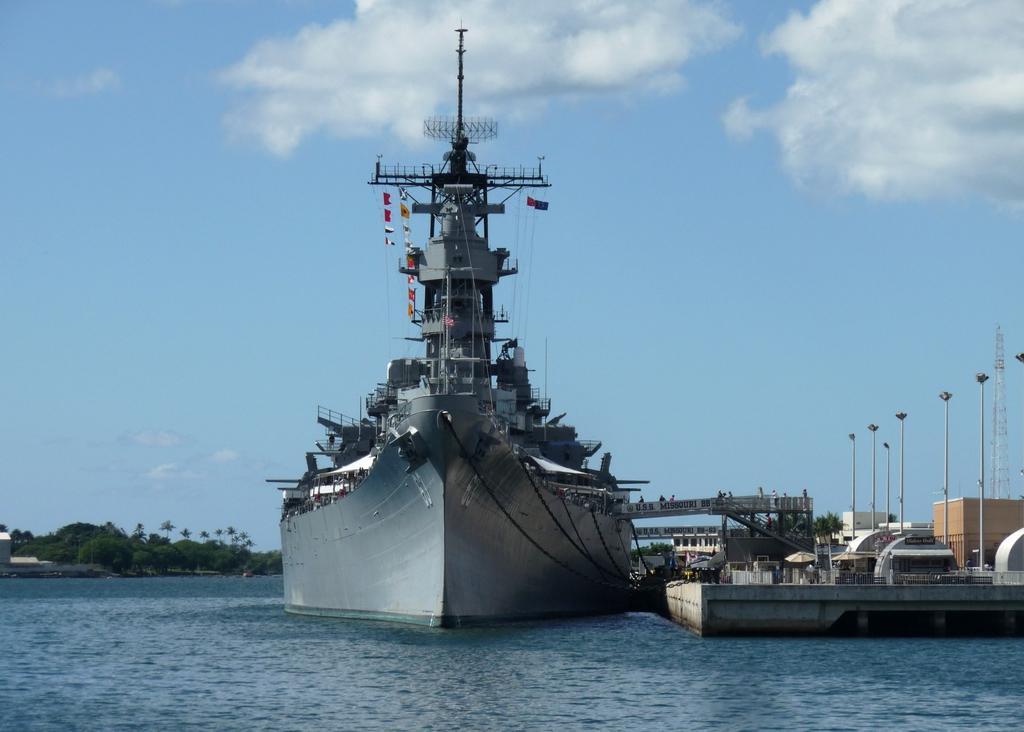Can you describe this image briefly? In this picture we can see a ship on the water. On the left side of the ship there are trees, houses and the sky/. On the left side of the ship there are poles and it looks like a harbor. 